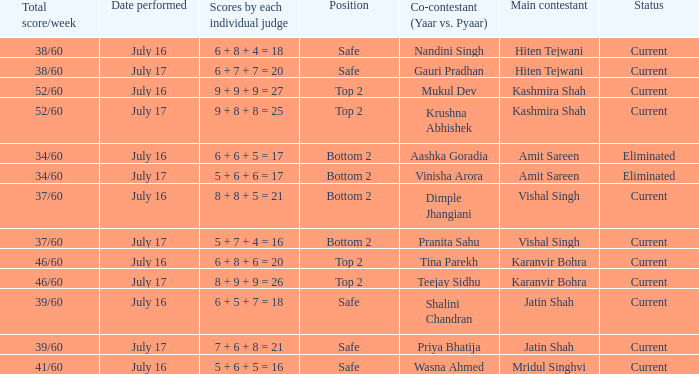Who performed with Tina Parekh? Karanvir Bohra. 